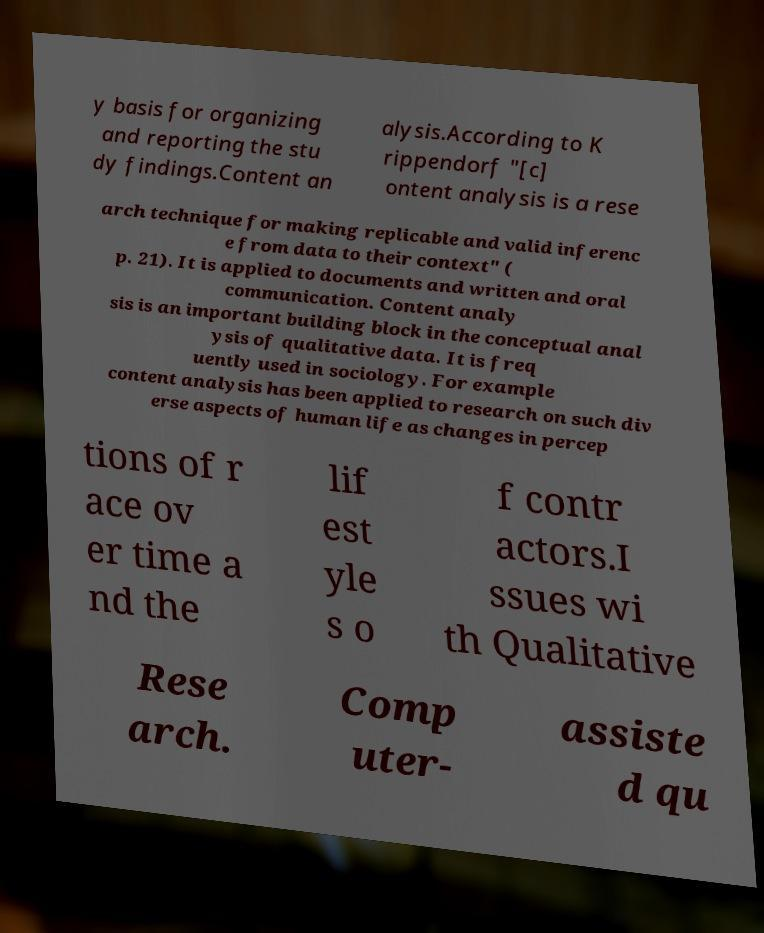Can you accurately transcribe the text from the provided image for me? y basis for organizing and reporting the stu dy findings.Content an alysis.According to K rippendorf "[c] ontent analysis is a rese arch technique for making replicable and valid inferenc e from data to their context" ( p. 21). It is applied to documents and written and oral communication. Content analy sis is an important building block in the conceptual anal ysis of qualitative data. It is freq uently used in sociology. For example content analysis has been applied to research on such div erse aspects of human life as changes in percep tions of r ace ov er time a nd the lif est yle s o f contr actors.I ssues wi th Qualitative Rese arch. Comp uter- assiste d qu 